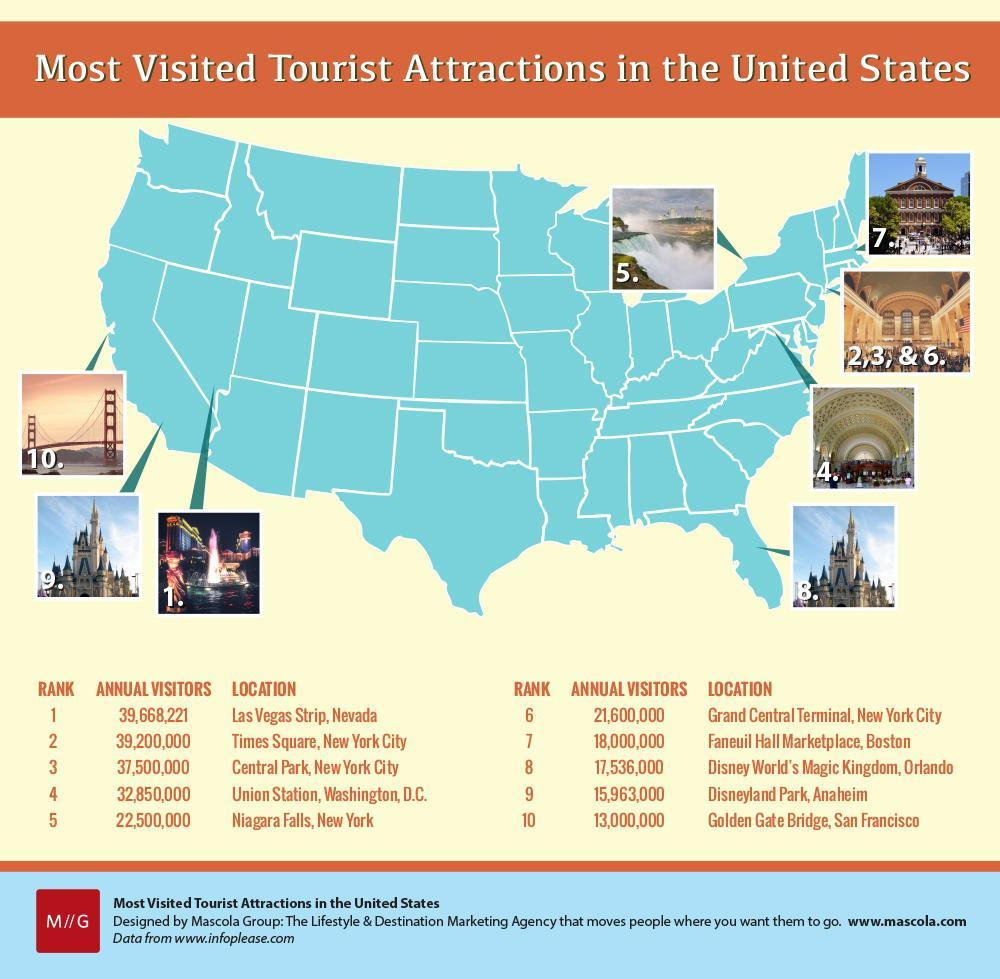Which attraction gets more visitors than Times Square?
Answer the question with a short phrase. Las Vegas Strip, Nevada What is the colour of the map of the US- blue or red? blue Which is the 7th most visited tourist attraction in the US? Faneuil Hall Marketplace, Boston 